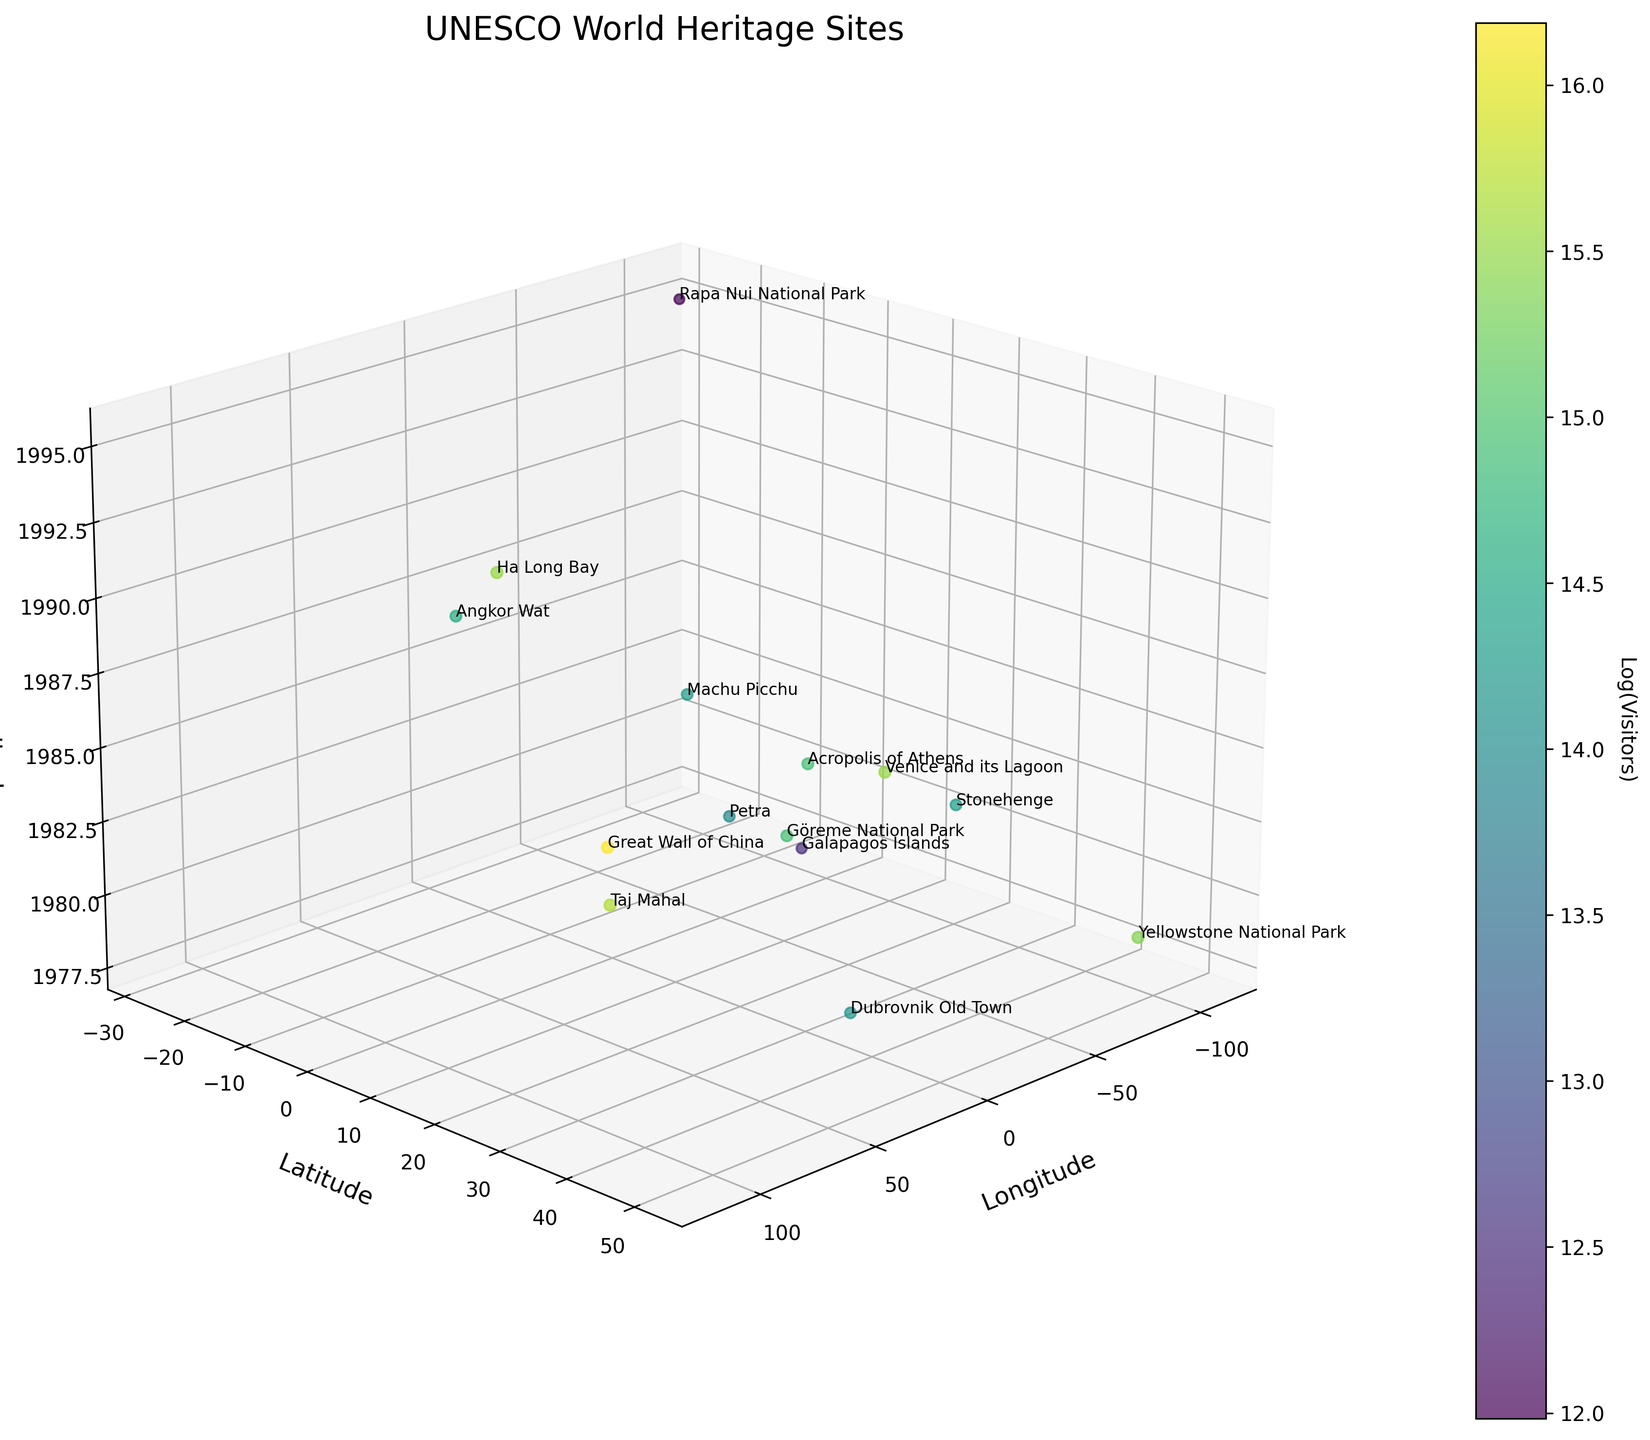What is the title of the figure? The title of the figure can be found at the top of the plot. It is labeled as "UNESCO World Heritage Sites."
Answer: UNESCO World Heritage Sites What does the color of the points represent? The color of the points is associated with the logarithm of the number of visitors to each site, as indicated by the color bar.
Answer: Log(Visitors) Which site has the highest number of visitors? The site with the highest number of visitors will be represented by the brightest or most intense color in the scatter plot. In this case, it is the Great Wall of China.
Answer: Great Wall of China Which axis represents the Year Inscribed? The axis labeled as "Year Inscribed" on the plot, which can be seen to be the "z" axis, indicates the year each site was inscribed as a UNESCO World Heritage Site.
Answer: z-axis How many data points are there in the plot? To determine the number of data points, we count the number of visible points in the 3D scatter plot. Each point represents a UNESCO World Heritage Site, and there are 15 points.
Answer: 15 Which site has both a high number of visitors and was inscribed before 1980? We look for a site that is high on the color scale (indicating many visitors) and has a z-value (Year Inscribed) below 1980. Yellowstone National Park fits this criterion.
Answer: Yellowstone National Park What is the geographical location (latitude and longitude) of Stonehenge? The geographical location can be found by locating Stonehenge on the plot and reading its latitude and longitude values from the axes. It is at approximately 51.1789, -1.8262.
Answer: 51.1789, -1.8262 Which site has the lowest number of visitors? The site with the lowest number of visitors will be the point with the darkest color on the plot. This is Rapa Nui National Park.
Answer: Rapa Nui National Park What is the relationship between the number of visitors and the year inscribed for the sites located at similar latitudes in North America? We examine the points around similar latitudes in North America and compare their visitor numbers and years inscribed. For instance, Yellowstone National Park (with its millions of visitors, inscribed in 1978) indicates that older inscriptions do not necessarily correlate with lower or higher visitor numbers.
Answer: No clear pattern Which site has geographical coordinates closest to the origin (0,0) on the plot? We need to locate the point with latitude and longitude values closest to (0,0). The Galapagos Islands are closest to the geographic origin on this plot.
Answer: Galapagos Islands 